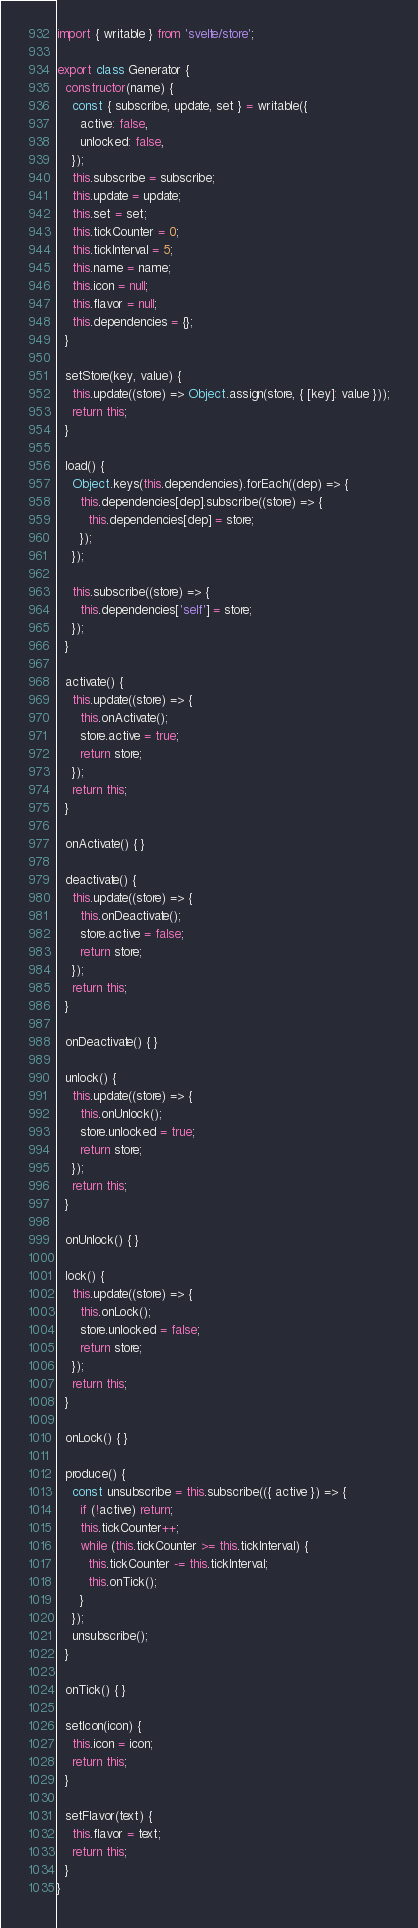Convert code to text. <code><loc_0><loc_0><loc_500><loc_500><_JavaScript_>import { writable } from 'svelte/store';

export class Generator {
  constructor(name) {
    const { subscribe, update, set } = writable({
      active: false,
      unlocked: false,
    });
    this.subscribe = subscribe;
    this.update = update;
    this.set = set;
    this.tickCounter = 0;
    this.tickInterval = 5;
    this.name = name;
    this.icon = null;
    this.flavor = null;
    this.dependencies = {};
  }

  setStore(key, value) {
    this.update((store) => Object.assign(store, { [key]: value }));
    return this;
  }

  load() {
    Object.keys(this.dependencies).forEach((dep) => {
      this.dependencies[dep].subscribe((store) => {
        this.dependencies[dep] = store;
      });
    });

    this.subscribe((store) => {
      this.dependencies['self'] = store;
    });
  }

  activate() {
    this.update((store) => {
      this.onActivate();
      store.active = true;
      return store;
    });
    return this;
  }

  onActivate() { }

  deactivate() {
    this.update((store) => {
      this.onDeactivate();
      store.active = false;
      return store;
    });
    return this;
  }

  onDeactivate() { }

  unlock() {
    this.update((store) => {
      this.onUnlock();
      store.unlocked = true;
      return store;
    });
    return this;
  }

  onUnlock() { }

  lock() {
    this.update((store) => {
      this.onLock();
      store.unlocked = false;
      return store;
    });
    return this;
  }

  onLock() { }

  produce() {
    const unsubscribe = this.subscribe(({ active }) => {
      if (!active) return;
      this.tickCounter++;
      while (this.tickCounter >= this.tickInterval) {
        this.tickCounter -= this.tickInterval;
        this.onTick();
      }
    });
    unsubscribe();
  }

  onTick() { }

  setIcon(icon) {
    this.icon = icon;
    return this;
  }

  setFlavor(text) {
    this.flavor = text;
    return this;
  }
}
</code> 